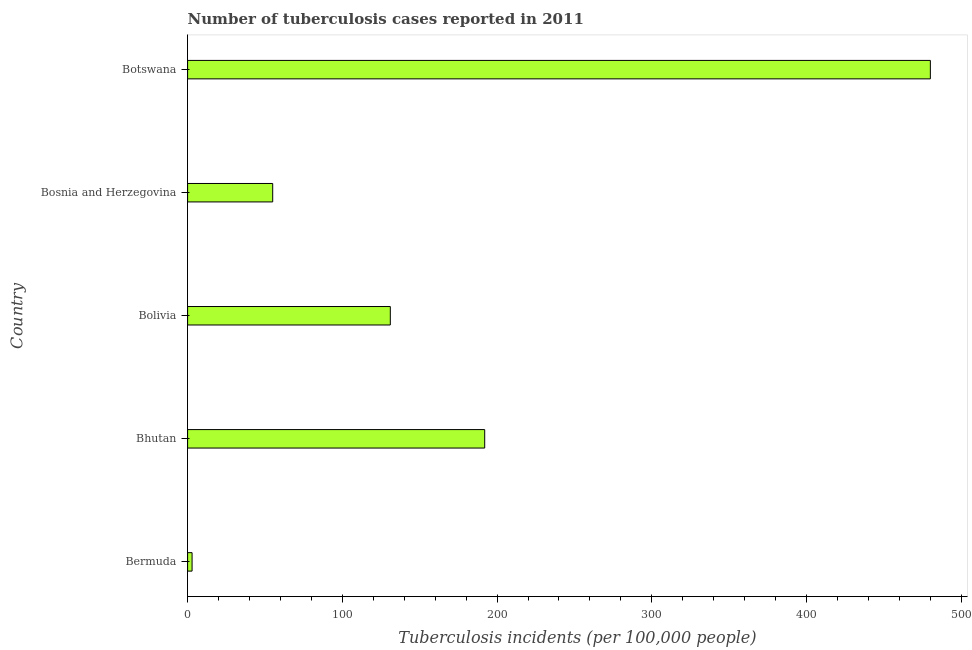Does the graph contain any zero values?
Give a very brief answer. No. What is the title of the graph?
Ensure brevity in your answer.  Number of tuberculosis cases reported in 2011. What is the label or title of the X-axis?
Give a very brief answer. Tuberculosis incidents (per 100,0 people). What is the label or title of the Y-axis?
Your answer should be very brief. Country. Across all countries, what is the maximum number of tuberculosis incidents?
Offer a terse response. 480. Across all countries, what is the minimum number of tuberculosis incidents?
Make the answer very short. 2.9. In which country was the number of tuberculosis incidents maximum?
Offer a terse response. Botswana. In which country was the number of tuberculosis incidents minimum?
Provide a short and direct response. Bermuda. What is the sum of the number of tuberculosis incidents?
Offer a terse response. 860.9. What is the difference between the number of tuberculosis incidents in Bolivia and Botswana?
Ensure brevity in your answer.  -349. What is the average number of tuberculosis incidents per country?
Ensure brevity in your answer.  172.18. What is the median number of tuberculosis incidents?
Provide a short and direct response. 131. What is the ratio of the number of tuberculosis incidents in Bolivia to that in Botswana?
Your answer should be very brief. 0.27. Is the number of tuberculosis incidents in Bermuda less than that in Bolivia?
Make the answer very short. Yes. Is the difference between the number of tuberculosis incidents in Bosnia and Herzegovina and Botswana greater than the difference between any two countries?
Make the answer very short. No. What is the difference between the highest and the second highest number of tuberculosis incidents?
Offer a very short reply. 288. Is the sum of the number of tuberculosis incidents in Bhutan and Bolivia greater than the maximum number of tuberculosis incidents across all countries?
Offer a very short reply. No. What is the difference between the highest and the lowest number of tuberculosis incidents?
Offer a terse response. 477.1. In how many countries, is the number of tuberculosis incidents greater than the average number of tuberculosis incidents taken over all countries?
Keep it short and to the point. 2. Are all the bars in the graph horizontal?
Your answer should be very brief. Yes. How many countries are there in the graph?
Keep it short and to the point. 5. What is the difference between two consecutive major ticks on the X-axis?
Your response must be concise. 100. Are the values on the major ticks of X-axis written in scientific E-notation?
Keep it short and to the point. No. What is the Tuberculosis incidents (per 100,000 people) of Bermuda?
Give a very brief answer. 2.9. What is the Tuberculosis incidents (per 100,000 people) of Bhutan?
Make the answer very short. 192. What is the Tuberculosis incidents (per 100,000 people) in Bolivia?
Give a very brief answer. 131. What is the Tuberculosis incidents (per 100,000 people) of Botswana?
Give a very brief answer. 480. What is the difference between the Tuberculosis incidents (per 100,000 people) in Bermuda and Bhutan?
Give a very brief answer. -189.1. What is the difference between the Tuberculosis incidents (per 100,000 people) in Bermuda and Bolivia?
Offer a very short reply. -128.1. What is the difference between the Tuberculosis incidents (per 100,000 people) in Bermuda and Bosnia and Herzegovina?
Offer a very short reply. -52.1. What is the difference between the Tuberculosis incidents (per 100,000 people) in Bermuda and Botswana?
Your answer should be compact. -477.1. What is the difference between the Tuberculosis incidents (per 100,000 people) in Bhutan and Bolivia?
Offer a terse response. 61. What is the difference between the Tuberculosis incidents (per 100,000 people) in Bhutan and Bosnia and Herzegovina?
Ensure brevity in your answer.  137. What is the difference between the Tuberculosis incidents (per 100,000 people) in Bhutan and Botswana?
Offer a very short reply. -288. What is the difference between the Tuberculosis incidents (per 100,000 people) in Bolivia and Botswana?
Your answer should be compact. -349. What is the difference between the Tuberculosis incidents (per 100,000 people) in Bosnia and Herzegovina and Botswana?
Provide a succinct answer. -425. What is the ratio of the Tuberculosis incidents (per 100,000 people) in Bermuda to that in Bhutan?
Give a very brief answer. 0.01. What is the ratio of the Tuberculosis incidents (per 100,000 people) in Bermuda to that in Bolivia?
Give a very brief answer. 0.02. What is the ratio of the Tuberculosis incidents (per 100,000 people) in Bermuda to that in Bosnia and Herzegovina?
Offer a very short reply. 0.05. What is the ratio of the Tuberculosis incidents (per 100,000 people) in Bermuda to that in Botswana?
Make the answer very short. 0.01. What is the ratio of the Tuberculosis incidents (per 100,000 people) in Bhutan to that in Bolivia?
Give a very brief answer. 1.47. What is the ratio of the Tuberculosis incidents (per 100,000 people) in Bhutan to that in Bosnia and Herzegovina?
Ensure brevity in your answer.  3.49. What is the ratio of the Tuberculosis incidents (per 100,000 people) in Bolivia to that in Bosnia and Herzegovina?
Your answer should be very brief. 2.38. What is the ratio of the Tuberculosis incidents (per 100,000 people) in Bolivia to that in Botswana?
Offer a very short reply. 0.27. What is the ratio of the Tuberculosis incidents (per 100,000 people) in Bosnia and Herzegovina to that in Botswana?
Your answer should be very brief. 0.12. 